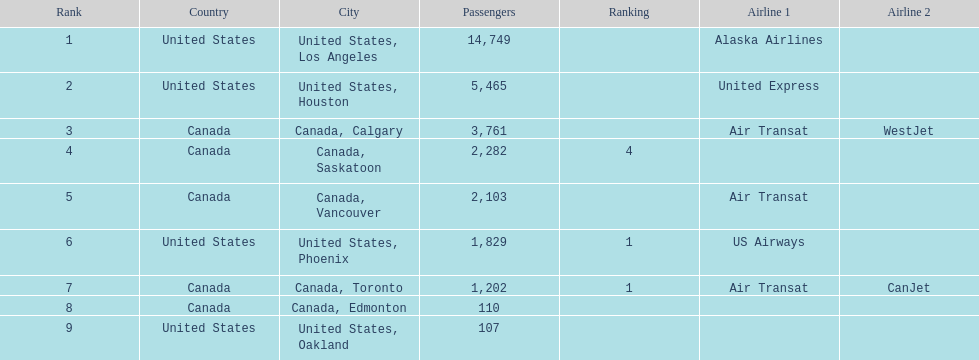Los angeles and what other city had about 19,000 passenger combined Canada, Calgary. 